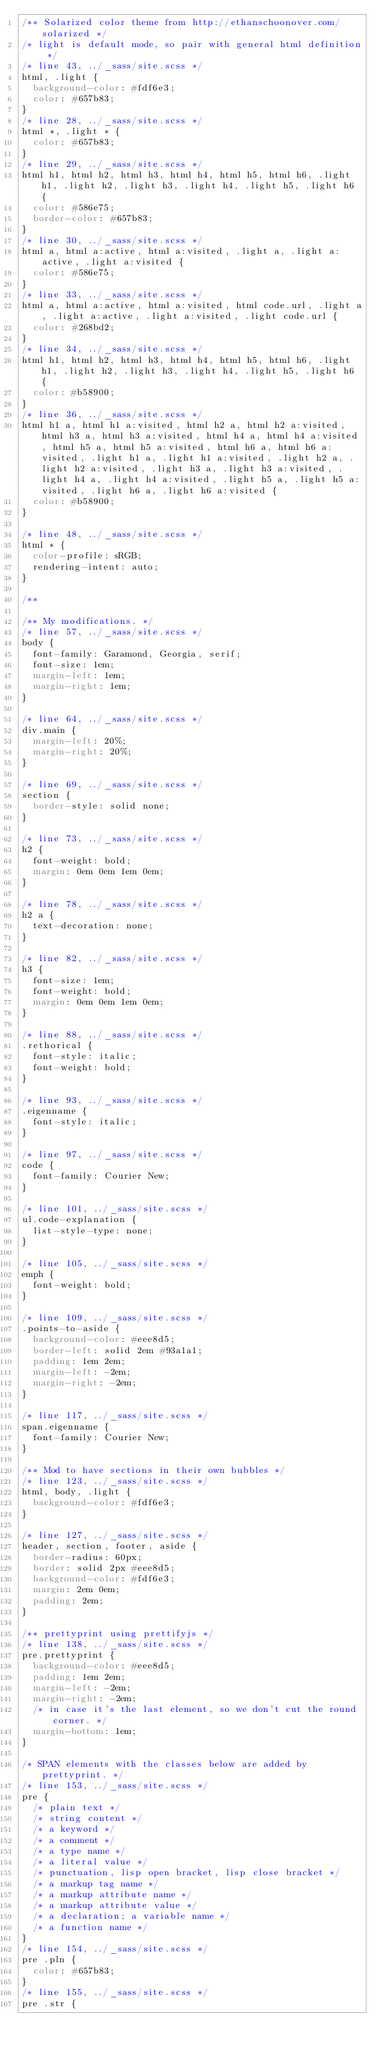<code> <loc_0><loc_0><loc_500><loc_500><_CSS_>/** Solarized color theme from http://ethanschoonover.com/solarized */
/* light is default mode, so pair with general html definition */
/* line 43, ../_sass/site.scss */
html, .light {
  background-color: #fdf6e3;
  color: #657b83;
}
/* line 28, ../_sass/site.scss */
html *, .light * {
  color: #657b83;
}
/* line 29, ../_sass/site.scss */
html h1, html h2, html h3, html h4, html h5, html h6, .light h1, .light h2, .light h3, .light h4, .light h5, .light h6 {
  color: #586e75;
  border-color: #657b83;
}
/* line 30, ../_sass/site.scss */
html a, html a:active, html a:visited, .light a, .light a:active, .light a:visited {
  color: #586e75;
}
/* line 33, ../_sass/site.scss */
html a, html a:active, html a:visited, html code.url, .light a, .light a:active, .light a:visited, .light code.url {
  color: #268bd2;
}
/* line 34, ../_sass/site.scss */
html h1, html h2, html h3, html h4, html h5, html h6, .light h1, .light h2, .light h3, .light h4, .light h5, .light h6 {
  color: #b58900;
}
/* line 36, ../_sass/site.scss */
html h1 a, html h1 a:visited, html h2 a, html h2 a:visited, html h3 a, html h3 a:visited, html h4 a, html h4 a:visited, html h5 a, html h5 a:visited, html h6 a, html h6 a:visited, .light h1 a, .light h1 a:visited, .light h2 a, .light h2 a:visited, .light h3 a, .light h3 a:visited, .light h4 a, .light h4 a:visited, .light h5 a, .light h5 a:visited, .light h6 a, .light h6 a:visited {
  color: #b58900;
}

/* line 48, ../_sass/site.scss */
html * {
  color-profile: sRGB;
  rendering-intent: auto;
}

/** 

/** My modifications. */
/* line 57, ../_sass/site.scss */
body {
  font-family: Garamond, Georgia, serif;
  font-size: 1em;
  margin-left: 1em;
  margin-right: 1em;
}

/* line 64, ../_sass/site.scss */
div.main {
  margin-left: 20%;
  margin-right: 20%;
}

/* line 69, ../_sass/site.scss */
section {
  border-style: solid none;
}

/* line 73, ../_sass/site.scss */
h2 {
  font-weight: bold;
  margin: 0em 0em 1em 0em;
}

/* line 78, ../_sass/site.scss */
h2 a {
  text-decoration: none;
}

/* line 82, ../_sass/site.scss */
h3 {
  font-size: 1em;
  font-weight: bold;
  margin: 0em 0em 1em 0em;
}

/* line 88, ../_sass/site.scss */
.rethorical {
  font-style: italic;
  font-weight: bold;
}

/* line 93, ../_sass/site.scss */
.eigenname {
  font-style: italic;
}

/* line 97, ../_sass/site.scss */
code {
  font-family: Courier New;
}

/* line 101, ../_sass/site.scss */
ul.code-explanation {
  list-style-type: none;
}

/* line 105, ../_sass/site.scss */
emph {
  font-weight: bold;
}

/* line 109, ../_sass/site.scss */
.points-to-aside {
  background-color: #eee8d5;
  border-left: solid 2em #93a1a1;
  padding: 1em 2em;
  margin-left: -2em;
  margin-right: -2em;
}

/* line 117, ../_sass/site.scss */
span.eigenname {
  font-family: Courier New;
}

/** Mod to have sections in their own bubbles */
/* line 123, ../_sass/site.scss */
html, body, .light {
  background-color: #fdf6e3;
}

/* line 127, ../_sass/site.scss */
header, section, footer, aside {
  border-radius: 60px;
  border: solid 2px #eee8d5;
  background-color: #fdf6e3;
  margin: 2em 0em;
  padding: 2em;
}

/** prettyprint using prettifyjs */
/* line 138, ../_sass/site.scss */
pre.prettyprint {
  background-color: #eee8d5;
  padding: 1em 2em;
  margin-left: -2em;
  margin-right: -2em;
  /* in case it's the last element, so we don't cut the round corner. */
  margin-bottom: 1em;
}

/* SPAN elements with the classes below are added by prettyprint. */
/* line 153, ../_sass/site.scss */
pre {
  /* plain text */
  /* string content */
  /* a keyword */
  /* a comment */
  /* a type name */
  /* a literal value */
  /* punctuation, lisp open bracket, lisp close bracket */
  /* a markup tag name */
  /* a markup attribute name */
  /* a markup attribute value */
  /* a declaration; a variable name */
  /* a function name */
}
/* line 154, ../_sass/site.scss */
pre .pln {
  color: #657b83;
}
/* line 155, ../_sass/site.scss */
pre .str {</code> 